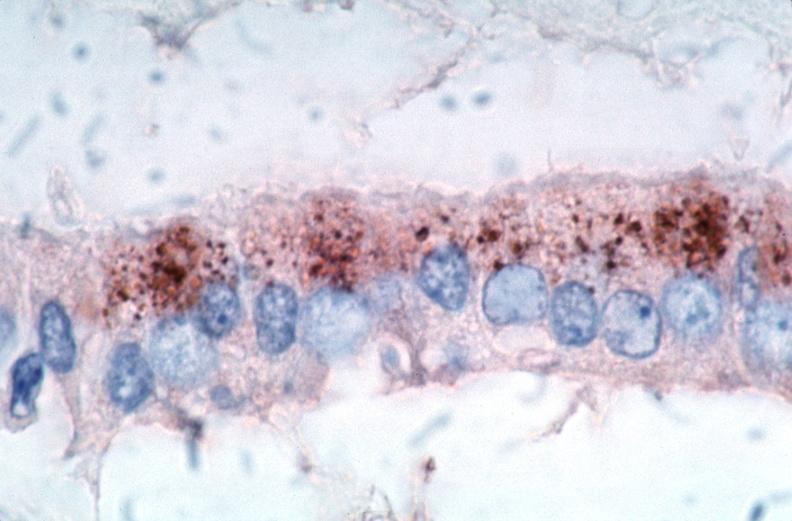what spotted fever, immunoperoxidase staining vessels for rickettsia rickettsii?
Answer the question using a single word or phrase. Rocky mountain 